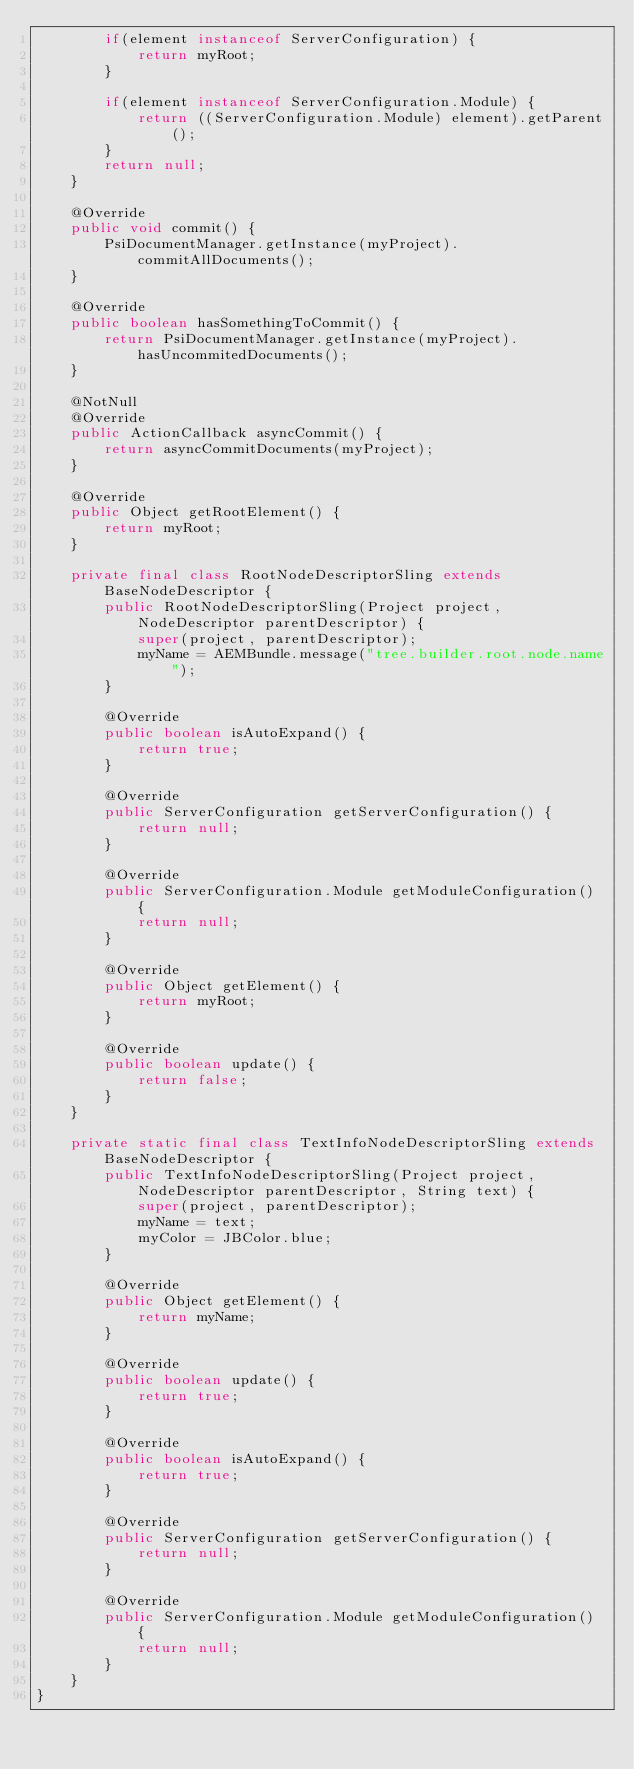Convert code to text. <code><loc_0><loc_0><loc_500><loc_500><_Java_>        if(element instanceof ServerConfiguration) {
            return myRoot;
        }

        if(element instanceof ServerConfiguration.Module) {
            return ((ServerConfiguration.Module) element).getParent();
        }
        return null;
    }

    @Override
    public void commit() {
        PsiDocumentManager.getInstance(myProject).commitAllDocuments();
    }

    @Override
    public boolean hasSomethingToCommit() {
        return PsiDocumentManager.getInstance(myProject).hasUncommitedDocuments();
    }

    @NotNull
    @Override
    public ActionCallback asyncCommit() {
        return asyncCommitDocuments(myProject);
    }

    @Override
    public Object getRootElement() {
        return myRoot;
    }

    private final class RootNodeDescriptorSling extends BaseNodeDescriptor {
        public RootNodeDescriptorSling(Project project, NodeDescriptor parentDescriptor) {
            super(project, parentDescriptor);
            myName = AEMBundle.message("tree.builder.root.node.name");
        }

        @Override
        public boolean isAutoExpand() {
            return true;
        }

        @Override
        public ServerConfiguration getServerConfiguration() {
            return null;
        }

        @Override
        public ServerConfiguration.Module getModuleConfiguration() {
            return null;
        }

        @Override
        public Object getElement() {
            return myRoot;
        }

        @Override
        public boolean update() {
            return false;
        }
    }

    private static final class TextInfoNodeDescriptorSling extends BaseNodeDescriptor {
        public TextInfoNodeDescriptorSling(Project project, NodeDescriptor parentDescriptor, String text) {
            super(project, parentDescriptor);
            myName = text;
            myColor = JBColor.blue;
        }

        @Override
        public Object getElement() {
            return myName;
        }

        @Override
        public boolean update() {
            return true;
        }

        @Override
        public boolean isAutoExpand() {
            return true;
        }

        @Override
        public ServerConfiguration getServerConfiguration() {
            return null;
        }

        @Override
        public ServerConfiguration.Module getModuleConfiguration() {
            return null;
        }
    }
}
</code> 